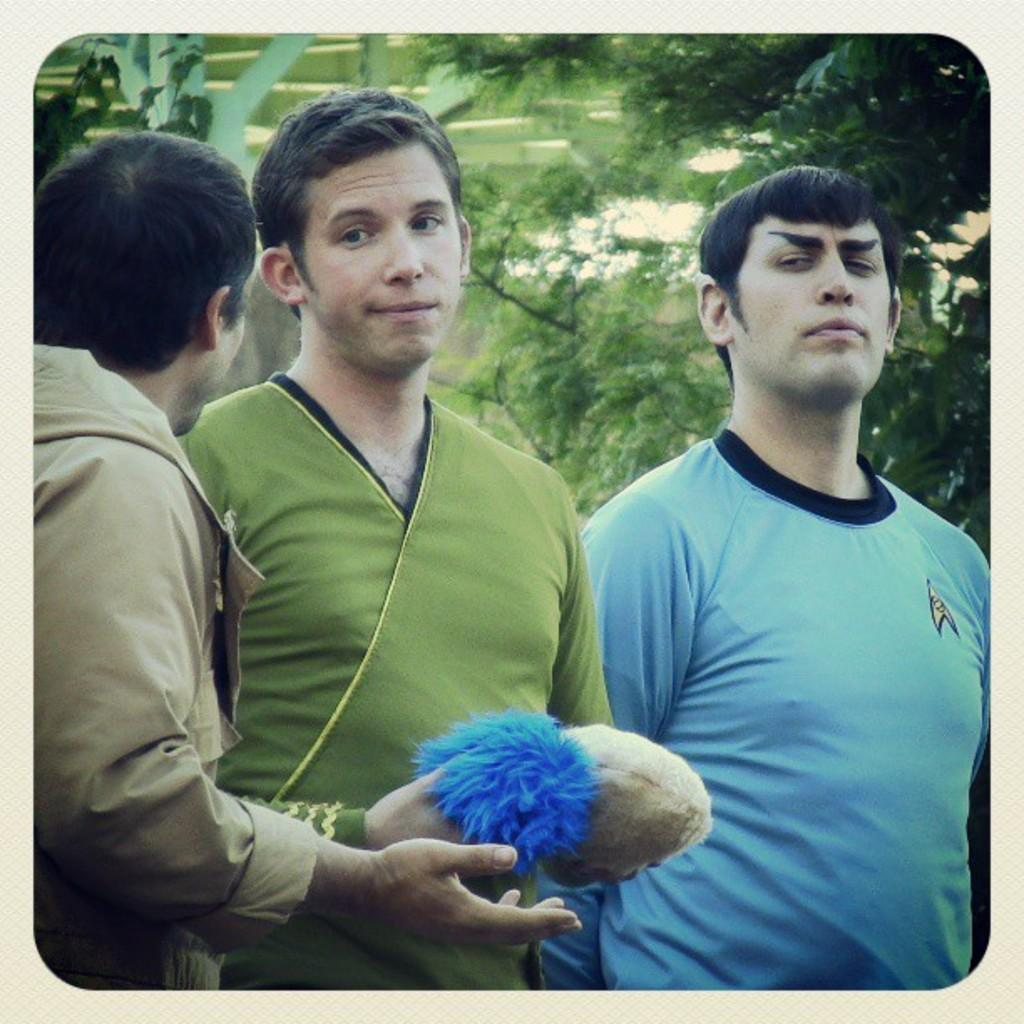How many people are in the foreground of the image? There are three men in the foreground of the image. What is one of the men doing with his hands? One of the men is holding two objects. What can be seen in the background of the image? There is greenery in the background of the image. What type of quilt design can be seen on the men's clothing in the image? There is no quilt or quilt design visible on the men's clothing in the image. What type of calculator is being used by one of the men in the image? There is no calculator present in the image. 